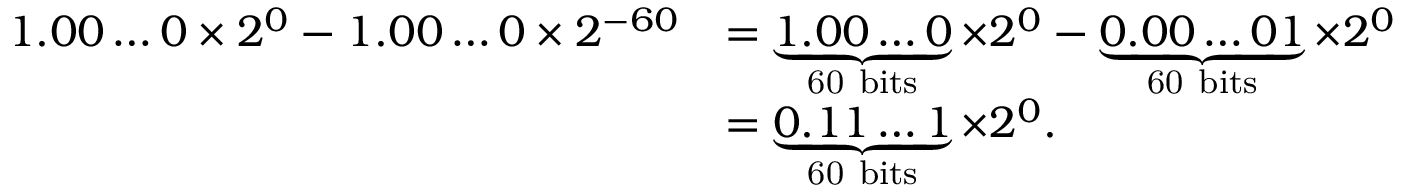<formula> <loc_0><loc_0><loc_500><loc_500>{ \begin{array} { r l } { 1 . 0 0 \dots 0 \times 2 ^ { 0 } - 1 . 0 0 \dots 0 \times 2 ^ { - 6 0 } } & { = \underbrace { 1 . 0 0 \dots 0 } _ { 6 0 b i t s } \times 2 ^ { 0 } - \underbrace { 0 . 0 0 \dots 0 1 } _ { 6 0 b i t s } \times 2 ^ { 0 } } \\ & { = \underbrace { 0 . 1 1 \dots 1 } _ { 6 0 b i t s } \times 2 ^ { 0 } . } \end{array} }</formula> 